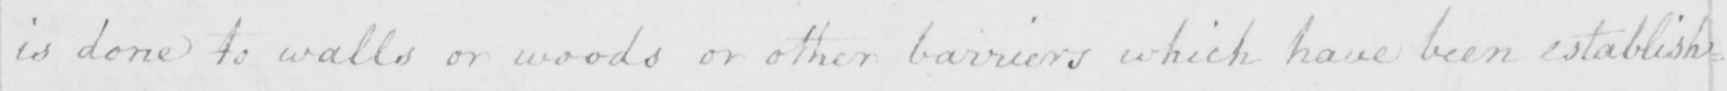Can you read and transcribe this handwriting? is done to walls or woods or other barriers which have been establish= 